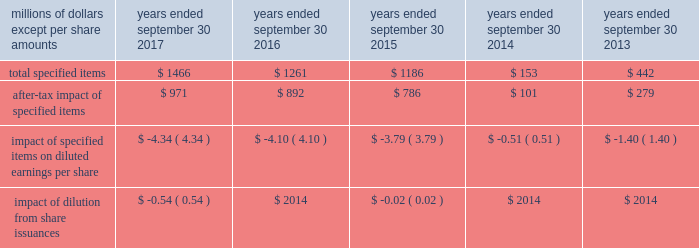( a ) excludes discontinued operations .
( b ) earnings before interest expense and taxes as a percent of average total assets .
( c ) total debt as a percent of the sum of total debt , shareholders 2019 equity and non-current deferred income tax liabilities .
The results above include the impact of the specified items detailed below .
Additional discussion regarding the specified items in fiscal years 2017 , 2016 and 2015 are provided in item 7 .
Management 2019s discussion and analysis of financial condition and results of operations. .
Item 7 .
Management 2019s discussion and analysis of financial condition and results of operations the following commentary should be read in conjunction with the consolidated financial statements and accompanying notes .
Within the tables presented throughout this discussion , certain columns may not add due to the use of rounded numbers for disclosure purposes .
Percentages and earnings per share amounts presented are calculated from the underlying amounts .
References to years throughout this discussion relate to our fiscal years , which end on september 30 .
Company overview description of the company and business segments becton , dickinson and company ( 201cbd 201d ) is a global medical technology company engaged in the development , manufacture and sale of a broad range of medical supplies , devices , laboratory equipment and diagnostic products used by healthcare institutions , life science researchers , clinical laboratories , the pharmaceutical industry and the general public .
The company's organizational structure is based upon two principal business segments , bd medical ( 201cmedical 201d ) and bd life sciences ( 201clife sciences 201d ) .
Bd 2019s products are manufactured and sold worldwide .
Our products are marketed in the united states and internationally through independent distribution channels and directly to end-users by bd and independent sales representatives .
We organize our operations outside the united states as follows : europe ; ema ( which includes the commonwealth of independent states , the middle east and africa ) ; greater asia ( which includes japan and asia pacific ) ; latin america ( which includes mexico , central america , the caribbean , and south america ) ; and canada .
We continue to pursue growth opportunities in emerging markets , which include the following geographic regions : eastern europe , the middle east , africa , latin america and certain countries within asia pacific .
We are primarily focused on certain countries whose healthcare systems are expanding , in particular , china and india .
Strategic objectives bd remains focused on delivering sustainable growth and shareholder value , while making appropriate investments for the future .
Bd management operates the business consistent with the following core strategies : 2022 to increase revenue growth by focusing on our core products , services and solutions that deliver greater benefits to patients , healthcare workers and researchers; .
Based on the management 2019s discussion and analysis of financial condition and results of operations what was the percent of approximate tax expense of the total specified items in 2018? 
Computations: ((1466 - 971) / 1466)
Answer: 0.33765. 